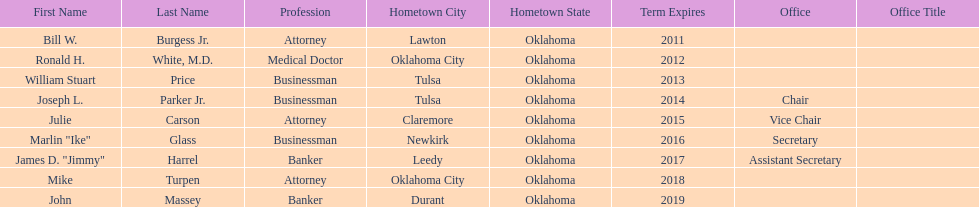Total number of members from lawton and oklahoma city 3. 